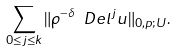Convert formula to latex. <formula><loc_0><loc_0><loc_500><loc_500>\sum _ { 0 \leq j \leq k } \| \rho ^ { - \delta } \ D e l ^ { j } u \| _ { 0 , p ; U } .</formula> 